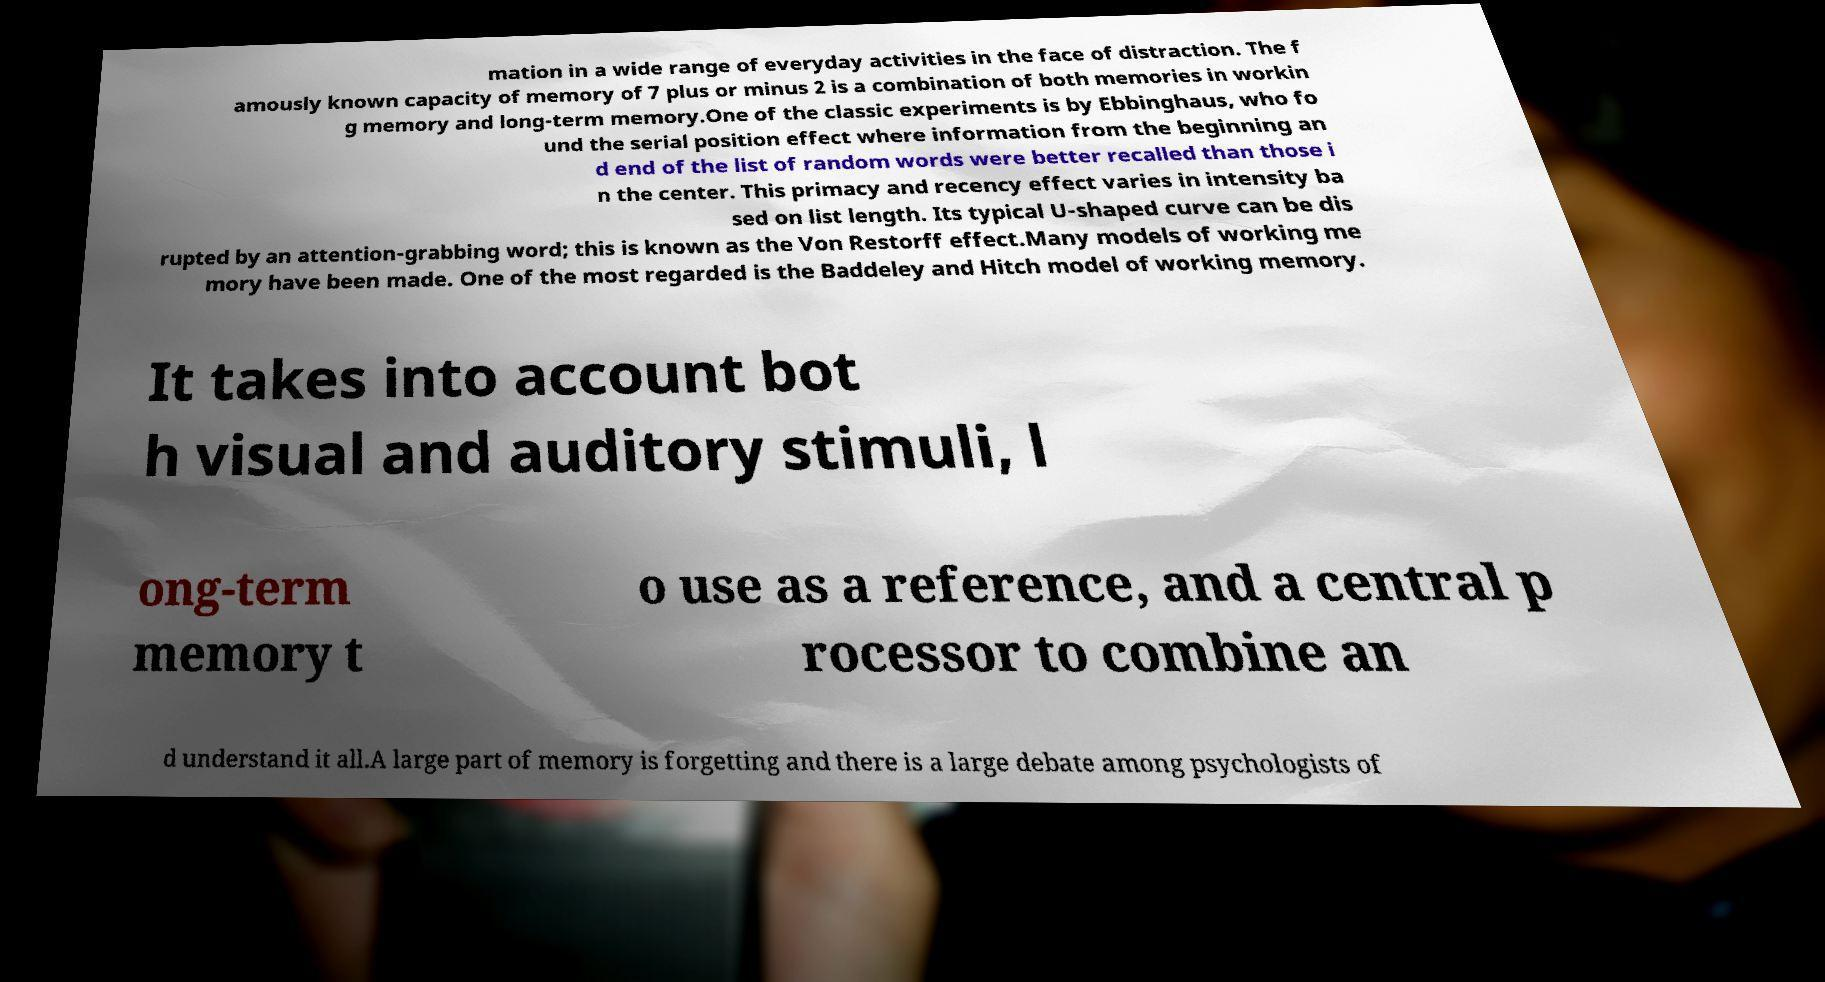Can you read and provide the text displayed in the image?This photo seems to have some interesting text. Can you extract and type it out for me? mation in a wide range of everyday activities in the face of distraction. The f amously known capacity of memory of 7 plus or minus 2 is a combination of both memories in workin g memory and long-term memory.One of the classic experiments is by Ebbinghaus, who fo und the serial position effect where information from the beginning an d end of the list of random words were better recalled than those i n the center. This primacy and recency effect varies in intensity ba sed on list length. Its typical U-shaped curve can be dis rupted by an attention-grabbing word; this is known as the Von Restorff effect.Many models of working me mory have been made. One of the most regarded is the Baddeley and Hitch model of working memory. It takes into account bot h visual and auditory stimuli, l ong-term memory t o use as a reference, and a central p rocessor to combine an d understand it all.A large part of memory is forgetting and there is a large debate among psychologists of 